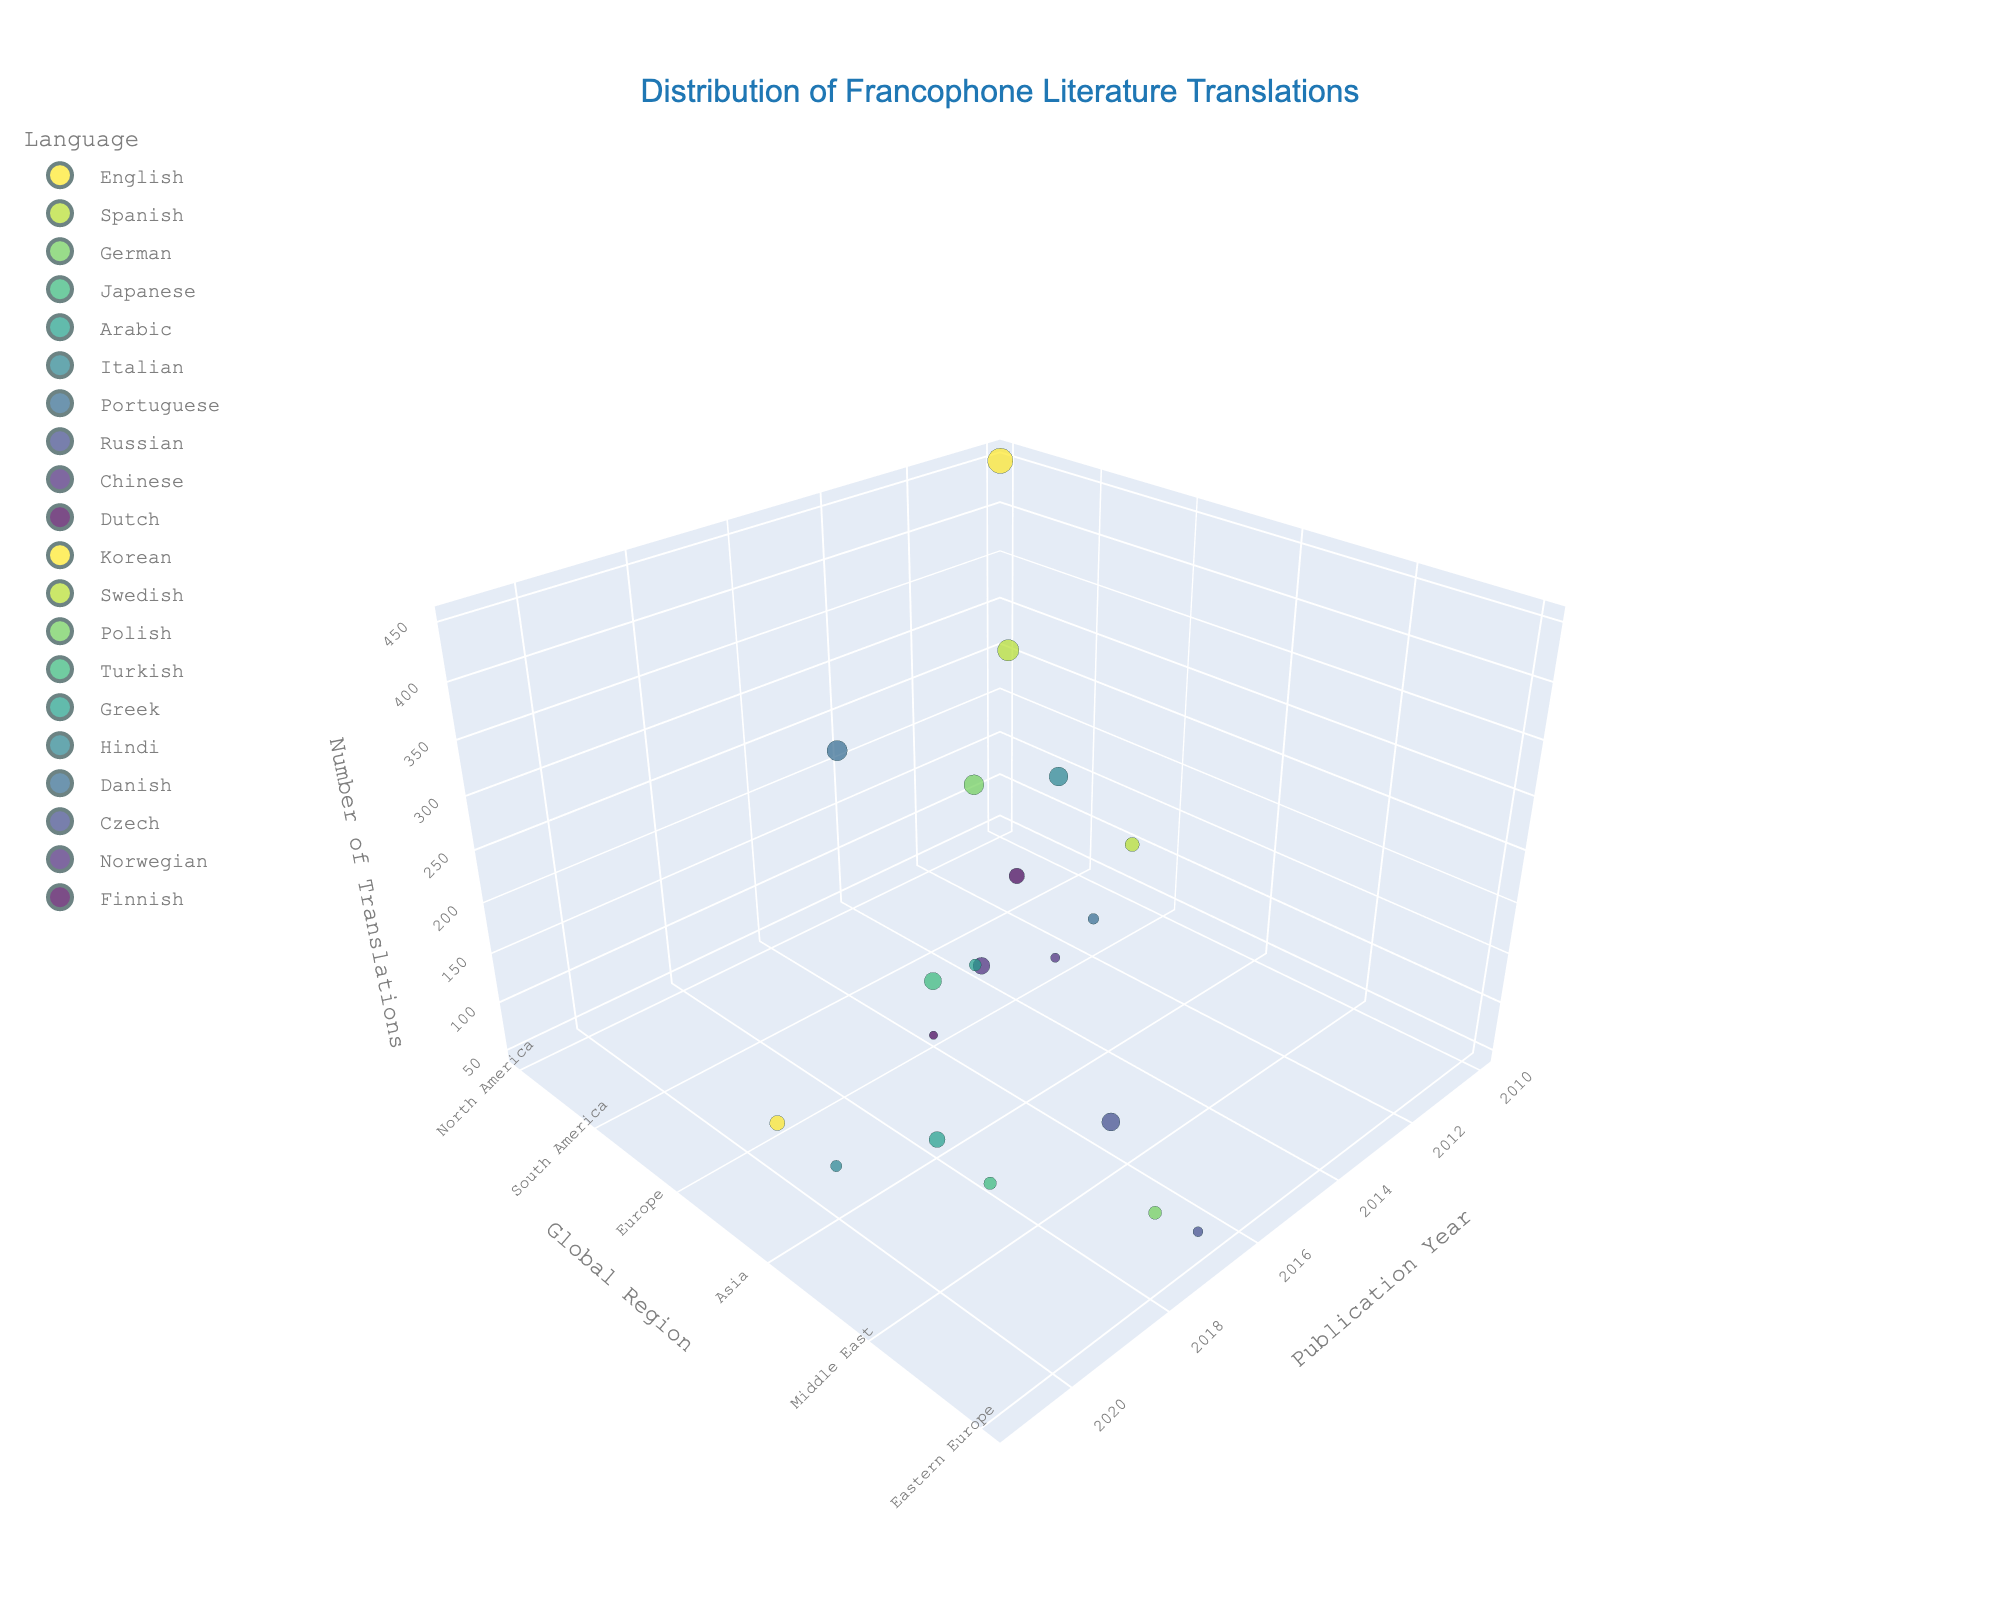What is the title of the figure? The title of the figure is usually displayed at the top. It can be directly read from the figure.
Answer: Distribution of Francophone Literature Translations What are the axes labels and their corresponding titles? Axes labels can be read directly from the figure. There are three axes in a 3D scatter plot and each has a title.
Answer: Publication Year, Global Region, Number of Translations Which language has the highest number of translations? Look at the size of the markers, as larger markers indicate a higher number of translations. Find the largest marker and identify its color/hover information.
Answer: English In which year was the maximum number of translations for Francophone literature in North America? Identify the data points within the North America region. Among those, look for the one with the highest z-axis value.
Answer: 2010 Compare the number of translations in 2015 between Europe and Asia. Which region has more translations? Find the data points for 2015 and compare the ones in Europe and Asia by looking at their z-axis values to determine which is higher.
Answer: Europe How many regions are represented in the plot? Count the unique labels or entries along the y-axis, which represents the global regions.
Answer: 6 Which language had the lowest number of translations and in what year? Find the smallest marker size and check the hover information to determine the language and publication year.
Answer: Finnish, 2016 What is the average number of translations for the languages in Asia? Locate data points in Asia. Sum their z-axis values and divide by the total number of data points for the average.
Answer: (210 + 200 + 160 + 90) / 4 = 165 Is there a trend in the number of translations over the years for Francophone literature? Look at the distribution of the sizes of markers along the x-axis from earlier years to later years and determine if there is an increasing or decreasing trend.
Answer: No clear trend Which region has the most diverse number of languages for translated Francophone literature? Count the number of different languages represented within each region on the y-axis.
Answer: Europe 